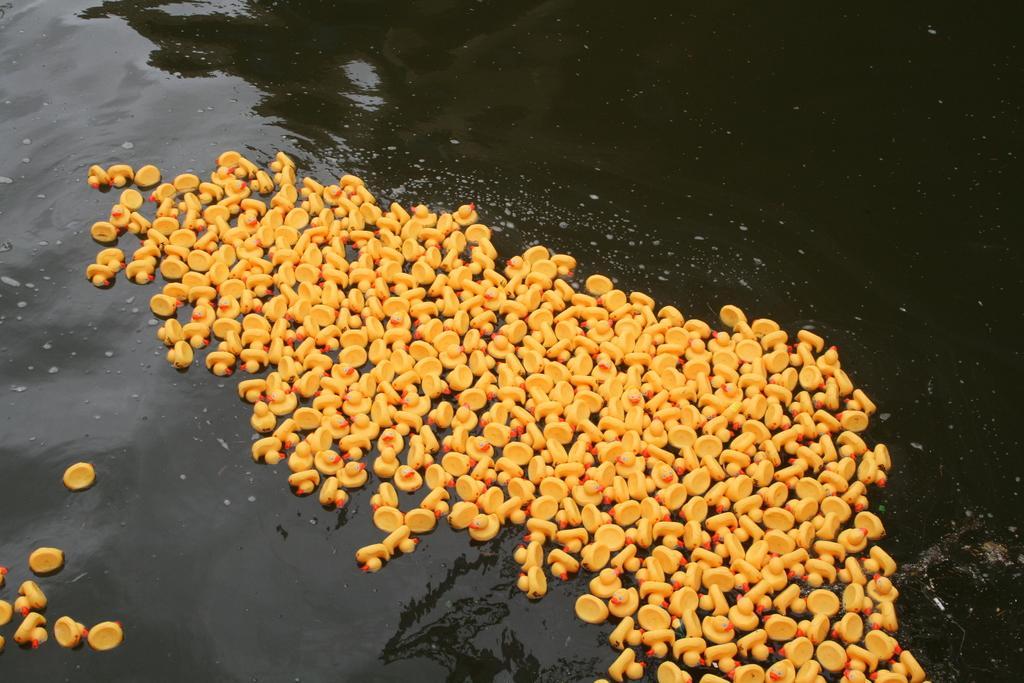How would you summarize this image in a sentence or two? There are toy ducks in the center of the image on the water surface. 